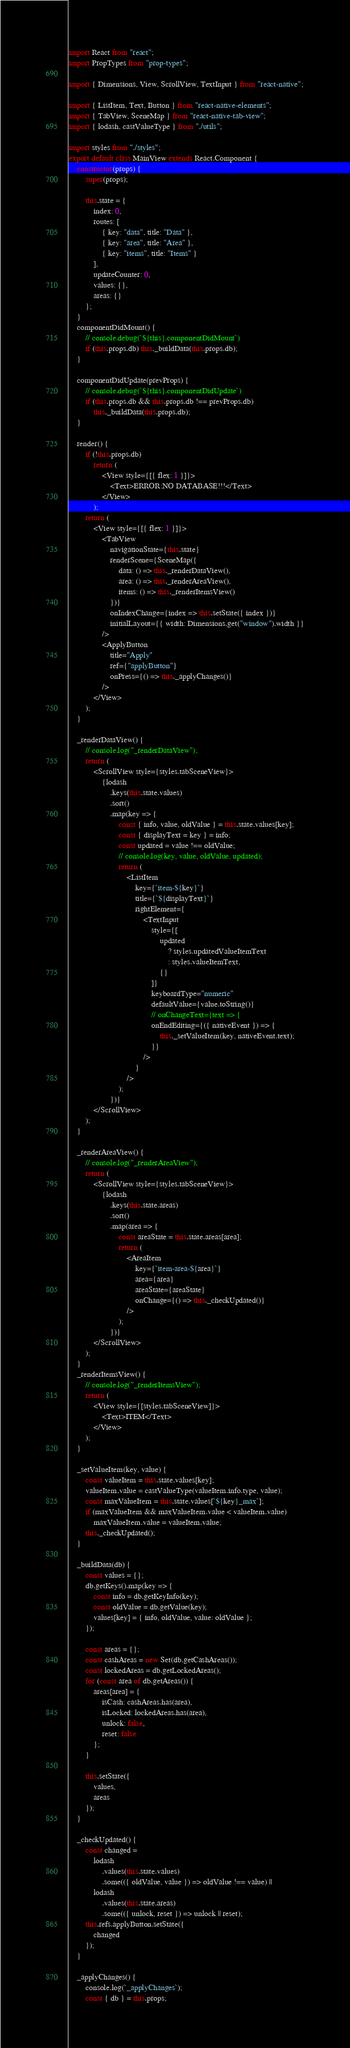<code> <loc_0><loc_0><loc_500><loc_500><_JavaScript_>import React from "react";
import PropTypes from "prop-types";

import { Dimensions, View, ScrollView, TextInput } from "react-native";

import { ListItem, Text, Button } from "react-native-elements";
import { TabView, SceneMap } from "react-native-tab-view";
import { lodash, castValueType } from "./utils";

import styles from "./styles";
export default class MainView extends React.Component {
	constructor(props) {
		super(props);

		this.state = {
			index: 0,
			routes: [
				{ key: "data", title: "Data" },
				{ key: "area", title: "Area" },
				{ key: "items", title: "Items" }
			],
			updateCounter: 0,
			values: {},
			areas: {}
		};
	}
	componentDidMount() {
		// console.debug(`${this}.componentDidMount`)
		if (this.props.db) this._buildData(this.props.db);
	}

	componentDidUpdate(prevProps) {
		// console.debug(`${this}.componentDidUpdate`)
		if (this.props.db && this.props.db !== prevProps.db)
			this._buildData(this.props.db);
	}

	render() {
		if (!this.props.db)
			return (
				<View style={[{ flex: 1 }]}>
					<Text>ERROR:NO DATABASE!!!</Text>
				</View>
			);
		return (
			<View style={[{ flex: 1 }]}>
				<TabView
					navigationState={this.state}
					renderScene={SceneMap({
						data: () => this._renderDataView(),
						area: () => this._renderAreaView(),
						items: () => this._renderItemsView()
					})}
					onIndexChange={index => this.setState({ index })}
					initialLayout={{ width: Dimensions.get("window").width }}
				/>
				<ApplyButton
					title="Apply"
					ref={"applyButton"}
					onPress={() => this._applyChanges()}
				/>
			</View>
		);
	}

	_renderDataView() {
		// console.log("_renderDataView");
		return (
			<ScrollView style={styles.tabSceneView}>
				{lodash
					.keys(this.state.values)
					.sort()
					.map(key => {
						const { info, value, oldValue } = this.state.values[key];
						const { displayText = key } = info;
						const updated = value !== oldValue;
						// console.log(key, value, oldValue, updated);
						return (
							<ListItem
								key={`item-${key}`}
								title={`${displayText}`}
								rightElement={
									<TextInput
										style={[
											updated
												? styles.updatedValueItemText
												: styles.valueItemText,
											{}
										]}
										keyboardType="numeric"
										defaultValue={value.toString()}
										// onChangeText={text => {
										onEndEditing={({ nativeEvent }) => {
											this._setValueItem(key, nativeEvent.text);
										}}
									/>
								}
							/>
						);
					})}
			</ScrollView>
		);
	}

	_renderAreaView() {
		// console.log("_renderAreaView");
		return (
			<ScrollView style={styles.tabSceneView}>
				{lodash
					.keys(this.state.areas)
					.sort()
					.map(area => {
						const areaState = this.state.areas[area];
						return (
							<AreaItem
								key={`item-area-${area}`}
								area={area}
								areaState={areaState}
								onChange={() => this._checkUpdated()}
							/>
						);
					})}
			</ScrollView>
		);
	}
	_renderItemsView() {
		// console.log("_renderItemsView");
		return (
			<View style={[styles.tabSceneView]}>
				<Text>ITEM</Text>
			</View>
		);
	}

	_setValueItem(key, value) {
		const valueItem = this.state.values[key];
		valueItem.value = castValueType(valueItem.info.type, value);
		const maxValueItem = this.state.values[`${key}_max`];
		if (maxValueItem && maxValueItem.value < valueItem.value)
			maxValueItem.value = valueItem.value;
		this._checkUpdated();
	}

	_buildData(db) {
		const values = {};
		db.getKeys().map(key => {
			const info = db.getKeyInfo(key);
			const oldValue = db.getValue(key);
			values[key] = { info, oldValue, value: oldValue };
		});

		const areas = {};
		const cashAreas = new Set(db.getCashAreas());
		const lockedAreas = db.getLockedAreas();
		for (const area of db.getAreas()) {
			areas[area] = {
				isCash: cashAreas.has(area),
				isLocked: lockedAreas.has(area),
				unlock: false,
				reset: false
			};
		}

		this.setState({
			values,
			areas
		});
	}

	_checkUpdated() {
		const changed =
			lodash
				.values(this.state.values)
				.some(({ oldValue, value }) => oldValue !== value) ||
			lodash
				.values(this.state.areas)
				.some(({ unlock, reset }) => unlock || reset);
		this.refs.applyButton.setState({
			changed
		});
	}

	_applyChanges() {
		console.log(`_applyChanges`);
		const { db } = this.props;
</code> 